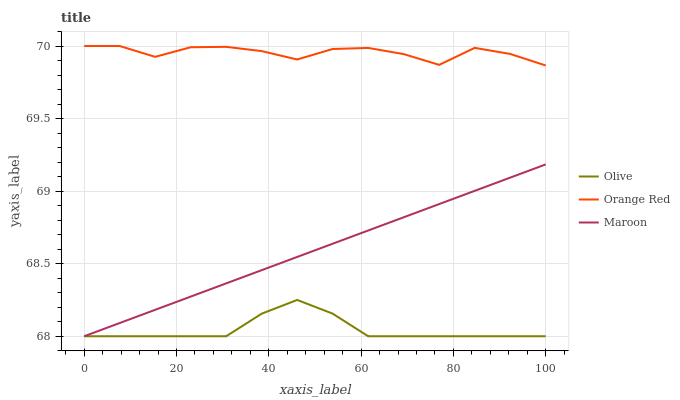Does Maroon have the minimum area under the curve?
Answer yes or no. No. Does Maroon have the maximum area under the curve?
Answer yes or no. No. Is Orange Red the smoothest?
Answer yes or no. No. Is Maroon the roughest?
Answer yes or no. No. Does Orange Red have the lowest value?
Answer yes or no. No. Does Maroon have the highest value?
Answer yes or no. No. Is Olive less than Orange Red?
Answer yes or no. Yes. Is Orange Red greater than Maroon?
Answer yes or no. Yes. Does Olive intersect Orange Red?
Answer yes or no. No. 